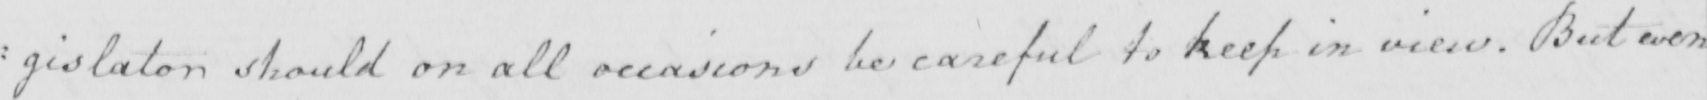Please provide the text content of this handwritten line. : gislator should on all occasions be careful to keep in view . But even 